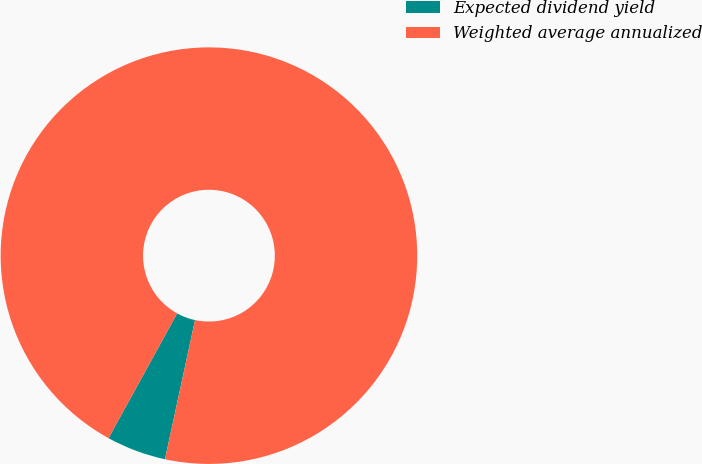Convert chart to OTSL. <chart><loc_0><loc_0><loc_500><loc_500><pie_chart><fcel>Expected dividend yield<fcel>Weighted average annualized<nl><fcel>4.62%<fcel>95.38%<nl></chart> 